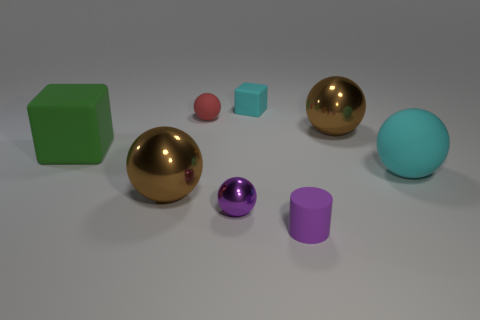Subtract all red spheres. How many spheres are left? 4 Subtract all large cyan matte spheres. How many spheres are left? 4 Subtract all blue balls. Subtract all blue cylinders. How many balls are left? 5 Add 1 large brown balls. How many objects exist? 9 Subtract all blocks. How many objects are left? 6 Subtract all tiny cubes. Subtract all large red metallic blocks. How many objects are left? 7 Add 7 purple cylinders. How many purple cylinders are left? 8 Add 5 tiny spheres. How many tiny spheres exist? 7 Subtract 1 red spheres. How many objects are left? 7 